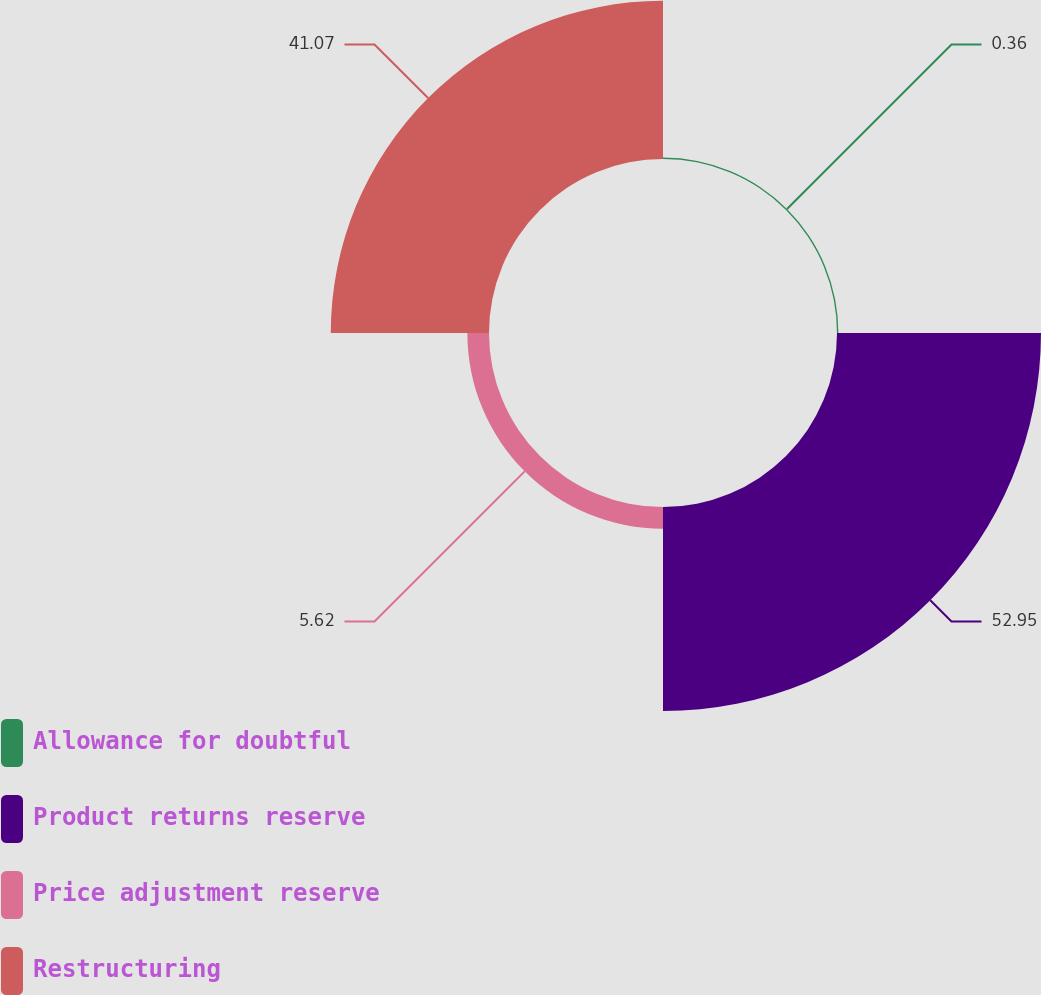<chart> <loc_0><loc_0><loc_500><loc_500><pie_chart><fcel>Allowance for doubtful<fcel>Product returns reserve<fcel>Price adjustment reserve<fcel>Restructuring<nl><fcel>0.36%<fcel>52.95%<fcel>5.62%<fcel>41.07%<nl></chart> 